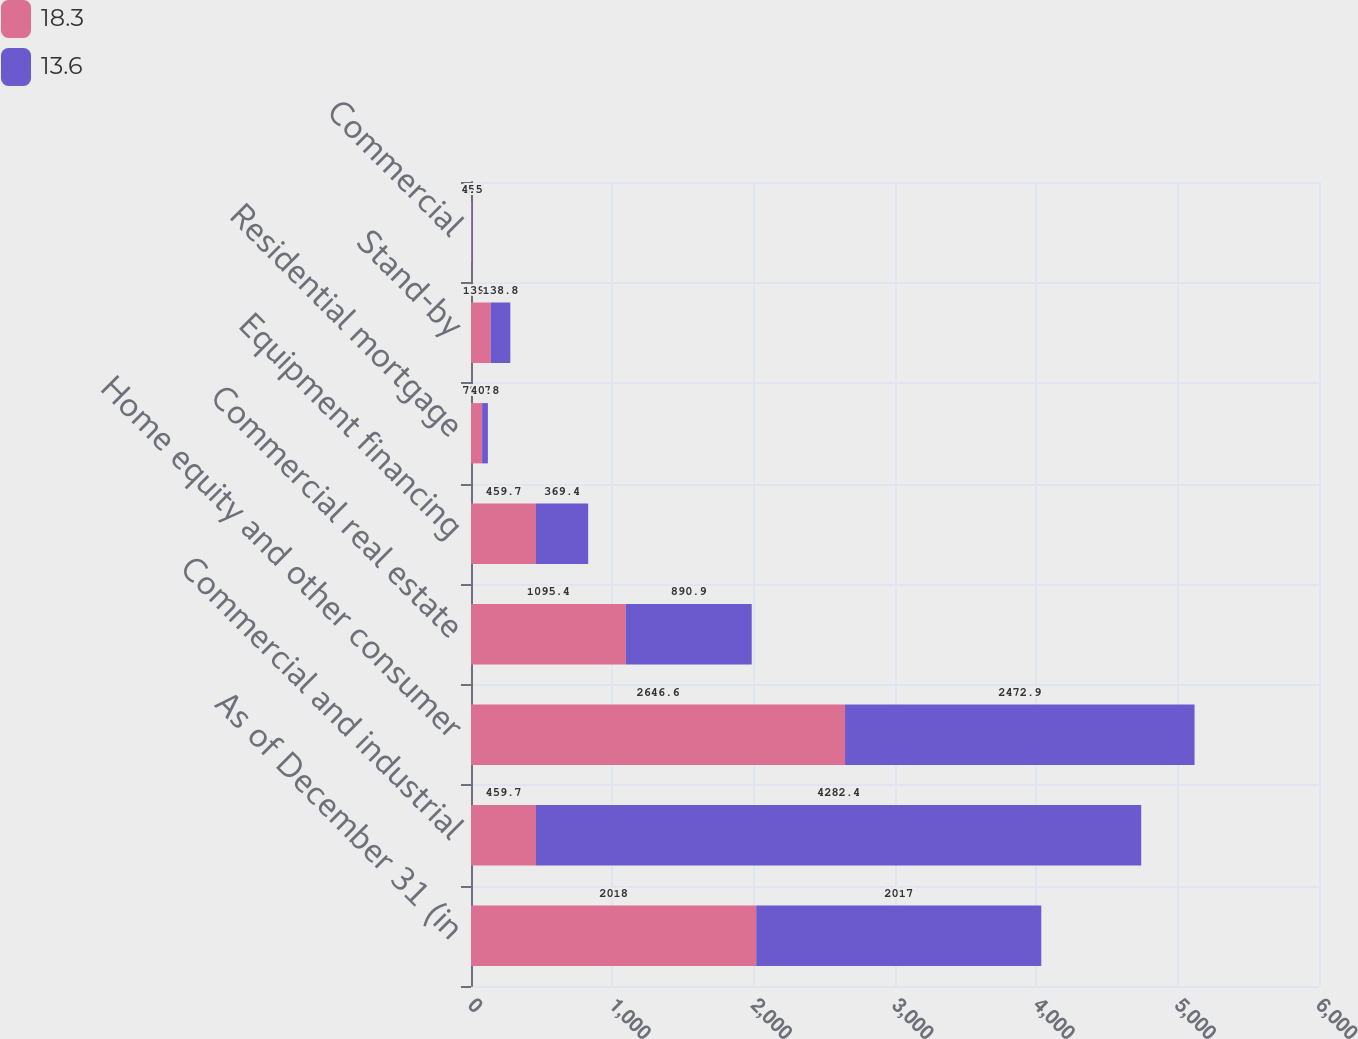<chart> <loc_0><loc_0><loc_500><loc_500><stacked_bar_chart><ecel><fcel>As of December 31 (in<fcel>Commercial and industrial<fcel>Home equity and other consumer<fcel>Commercial real estate<fcel>Equipment financing<fcel>Residential mortgage<fcel>Stand-by<fcel>Commercial<nl><fcel>18.3<fcel>2018<fcel>459.7<fcel>2646.6<fcel>1095.4<fcel>459.7<fcel>78.7<fcel>139.4<fcel>5<nl><fcel>13.6<fcel>2017<fcel>4282.4<fcel>2472.9<fcel>890.9<fcel>369.4<fcel>40.8<fcel>138.8<fcel>4.5<nl></chart> 